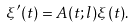Convert formula to latex. <formula><loc_0><loc_0><loc_500><loc_500>\xi ^ { \prime } ( t ) = A ( t ; l ) \xi ( t ) .</formula> 